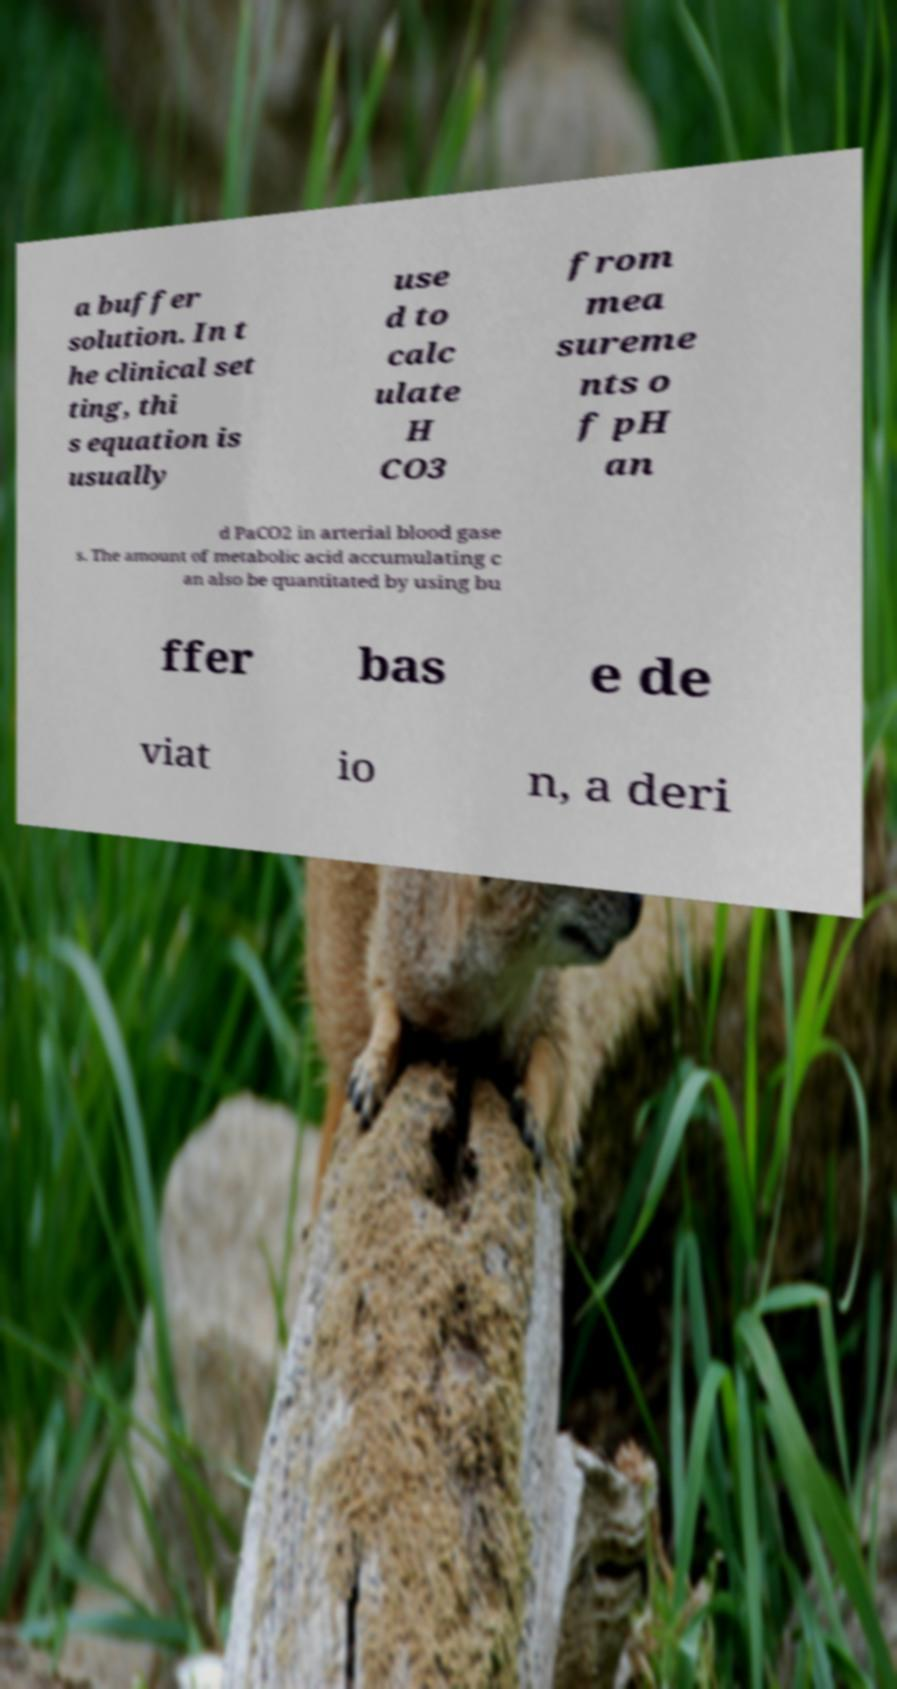I need the written content from this picture converted into text. Can you do that? a buffer solution. In t he clinical set ting, thi s equation is usually use d to calc ulate H CO3 from mea sureme nts o f pH an d PaCO2 in arterial blood gase s. The amount of metabolic acid accumulating c an also be quantitated by using bu ffer bas e de viat io n, a deri 